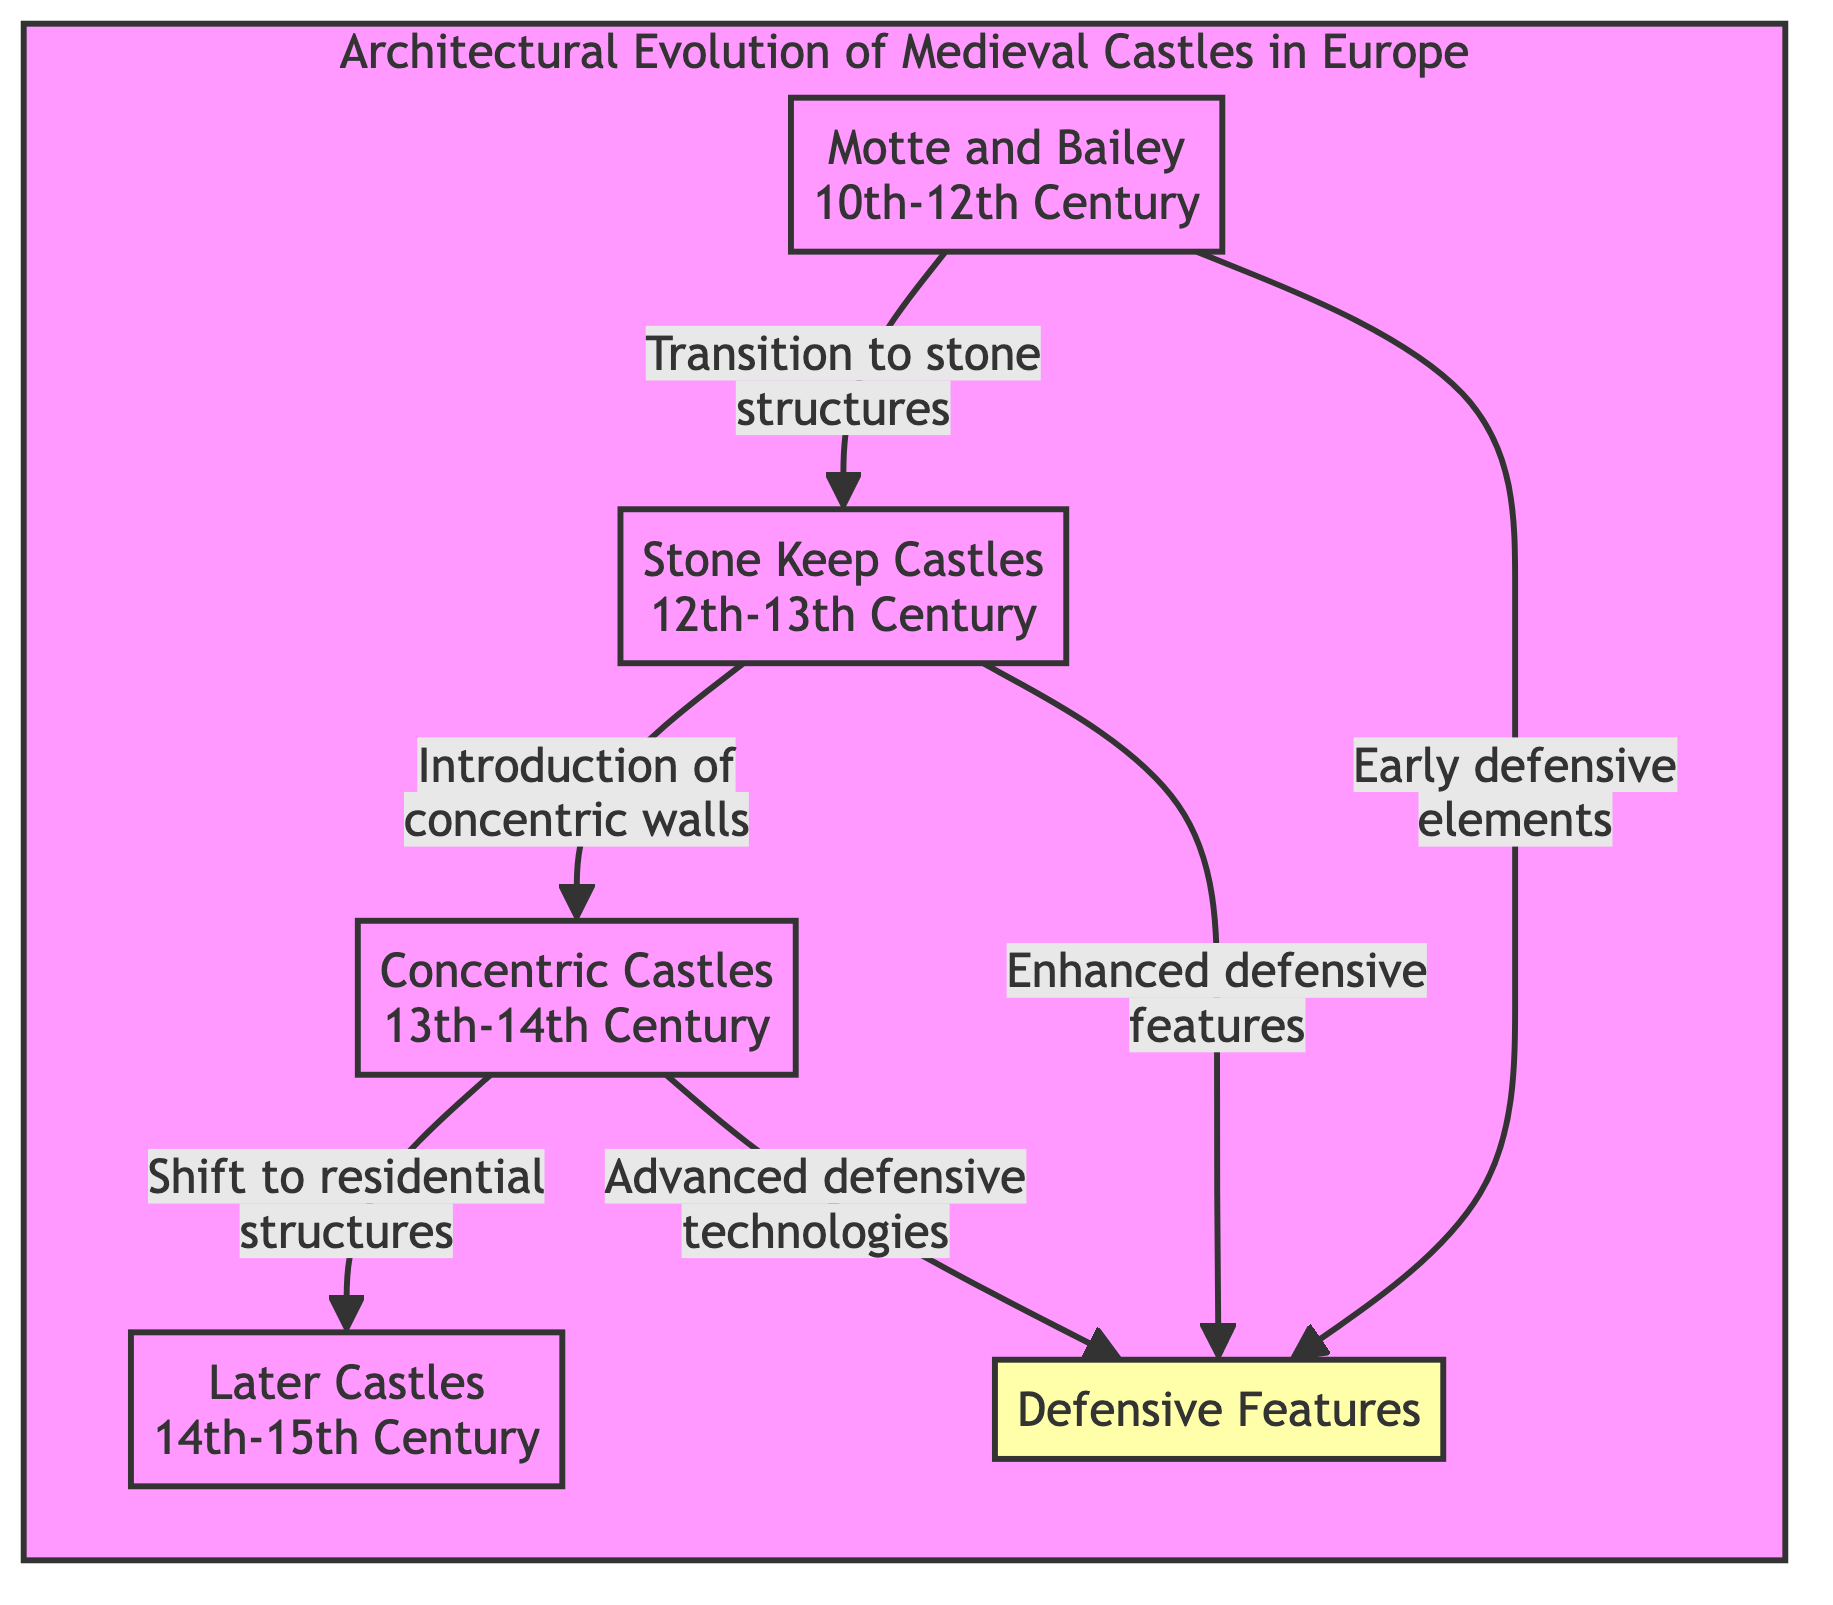What markers indicate the transition from wood to stone structures? The transition from wood to stone structures is represented by the arrow leading from "Motte and Bailey" to "Stone Keep Castles," highlighting the development of fortifications in the indicated period.
Answer: Stone Keep Castles Which castle type introduced concentric walls? The diagram indicates that "Concentric Castles" is the type that introduced concentric walls, as noted in the flow from "Stone Keep Castles" to this node.
Answer: Concentric Castles How many types of castles are represented in the diagram? By counting the nodes labeled with castle types in the diagram, we find there are four distinct types: "Motte and Bailey," "Stone Keep Castles," "Concentric Castles," and "Later Castles."
Answer: Four What key development occurred in the 14th to 15th century? The diagram states that during the 14th to 15th century, there was a shift toward residential structures, which is represented by the arrow leading to "Later Castles."
Answer: Residential structures What are the three advancements in defensive features across the castle types? The defensive features evolve from "Early defensive elements" at the "Motte and Bailey" stage, to "Enhanced defensive features" in "Stone Keep Castles," and "Advanced defensive technologies" with "Concentric Castles," indicating a progressive development of defense strategies over time.
Answer: Early, Enhanced, Advanced Which castle type is associated with the introduction of advanced defensive technologies? The introduction of advanced defensive technologies is specifically linked to "Concentric Castles," shown through the connector arrow in the diagram from "Concentric Castles" to the defensive features.
Answer: Concentric Castles How does the diagram illustrate the architectural evolution timeline? The timeline is visually represented by the downward flow from "Motte and Bailey" to "Later Castles," indicating a chronological progression from the 10th to 15th century across the types of castles.
Answer: Downward flow What type of diagram is used to represent information about medieval castles? The diagram presented is a flowchart, which effectively illustrates the relationships and transitions between different stages of medieval castle architecture over time.
Answer: Flowchart 